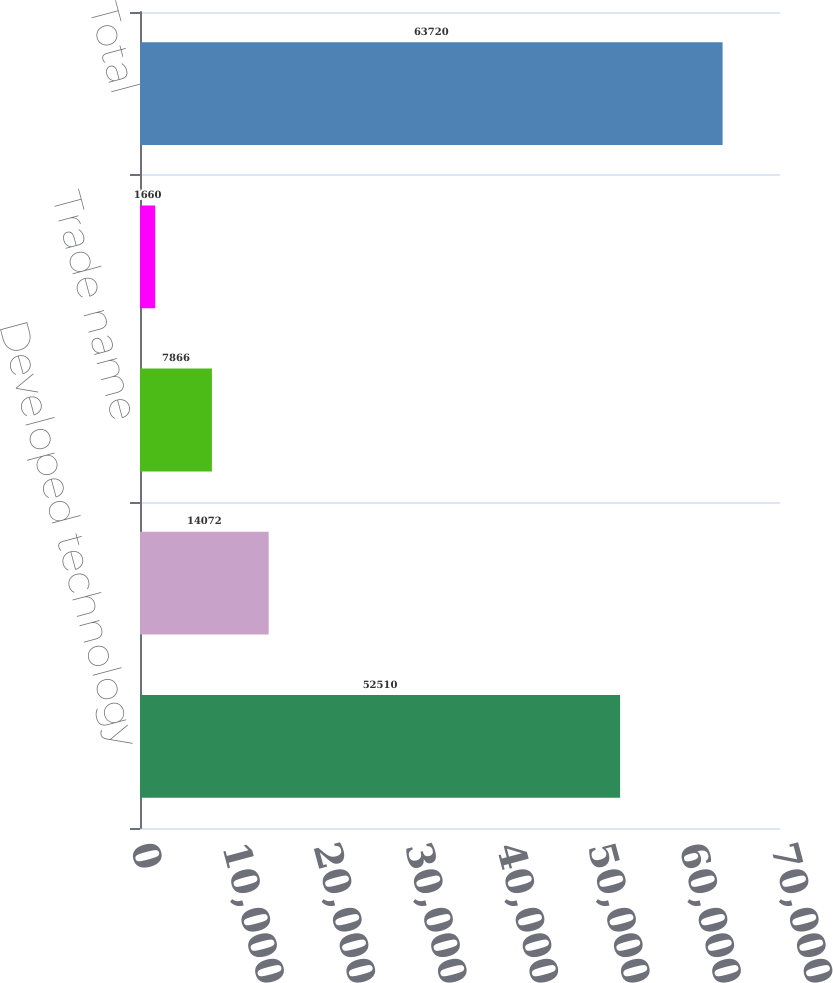<chart> <loc_0><loc_0><loc_500><loc_500><bar_chart><fcel>Developed technology<fcel>Customer relationships<fcel>Trade name<fcel>Others<fcel>Total<nl><fcel>52510<fcel>14072<fcel>7866<fcel>1660<fcel>63720<nl></chart> 